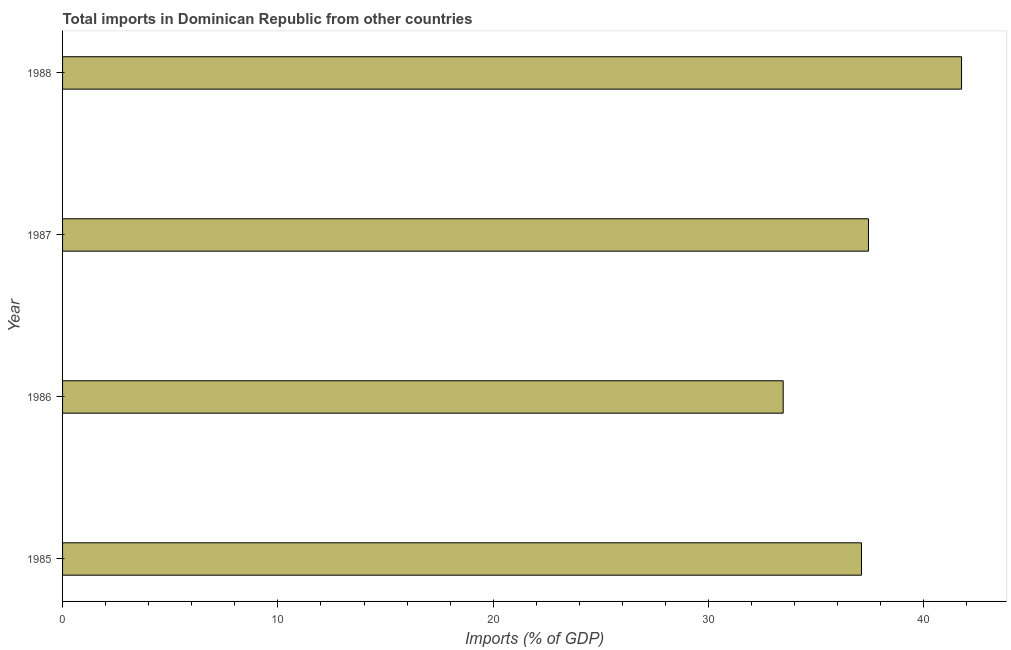Does the graph contain grids?
Your answer should be very brief. No. What is the title of the graph?
Give a very brief answer. Total imports in Dominican Republic from other countries. What is the label or title of the X-axis?
Keep it short and to the point. Imports (% of GDP). What is the label or title of the Y-axis?
Provide a short and direct response. Year. What is the total imports in 1988?
Offer a very short reply. 41.75. Across all years, what is the maximum total imports?
Offer a very short reply. 41.75. Across all years, what is the minimum total imports?
Keep it short and to the point. 33.46. In which year was the total imports maximum?
Keep it short and to the point. 1988. In which year was the total imports minimum?
Your answer should be compact. 1986. What is the sum of the total imports?
Ensure brevity in your answer.  149.74. What is the difference between the total imports in 1985 and 1988?
Your answer should be compact. -4.64. What is the average total imports per year?
Provide a short and direct response. 37.44. What is the median total imports?
Make the answer very short. 37.26. In how many years, is the total imports greater than 40 %?
Offer a very short reply. 1. Do a majority of the years between 1986 and 1987 (inclusive) have total imports greater than 10 %?
Offer a very short reply. Yes. What is the ratio of the total imports in 1987 to that in 1988?
Your answer should be very brief. 0.9. Is the total imports in 1986 less than that in 1988?
Your answer should be compact. Yes. Is the difference between the total imports in 1986 and 1988 greater than the difference between any two years?
Offer a very short reply. Yes. What is the difference between the highest and the second highest total imports?
Keep it short and to the point. 4.32. Is the sum of the total imports in 1985 and 1987 greater than the maximum total imports across all years?
Your answer should be very brief. Yes. What is the difference between the highest and the lowest total imports?
Provide a short and direct response. 8.28. In how many years, is the total imports greater than the average total imports taken over all years?
Keep it short and to the point. 1. How many bars are there?
Your response must be concise. 4. What is the Imports (% of GDP) of 1985?
Your response must be concise. 37.1. What is the Imports (% of GDP) of 1986?
Offer a terse response. 33.46. What is the Imports (% of GDP) in 1987?
Offer a very short reply. 37.42. What is the Imports (% of GDP) in 1988?
Your response must be concise. 41.75. What is the difference between the Imports (% of GDP) in 1985 and 1986?
Ensure brevity in your answer.  3.64. What is the difference between the Imports (% of GDP) in 1985 and 1987?
Give a very brief answer. -0.32. What is the difference between the Imports (% of GDP) in 1985 and 1988?
Your answer should be compact. -4.64. What is the difference between the Imports (% of GDP) in 1986 and 1987?
Your response must be concise. -3.96. What is the difference between the Imports (% of GDP) in 1986 and 1988?
Your answer should be very brief. -8.28. What is the difference between the Imports (% of GDP) in 1987 and 1988?
Ensure brevity in your answer.  -4.32. What is the ratio of the Imports (% of GDP) in 1985 to that in 1986?
Ensure brevity in your answer.  1.11. What is the ratio of the Imports (% of GDP) in 1985 to that in 1988?
Give a very brief answer. 0.89. What is the ratio of the Imports (% of GDP) in 1986 to that in 1987?
Your answer should be compact. 0.89. What is the ratio of the Imports (% of GDP) in 1986 to that in 1988?
Give a very brief answer. 0.8. What is the ratio of the Imports (% of GDP) in 1987 to that in 1988?
Give a very brief answer. 0.9. 